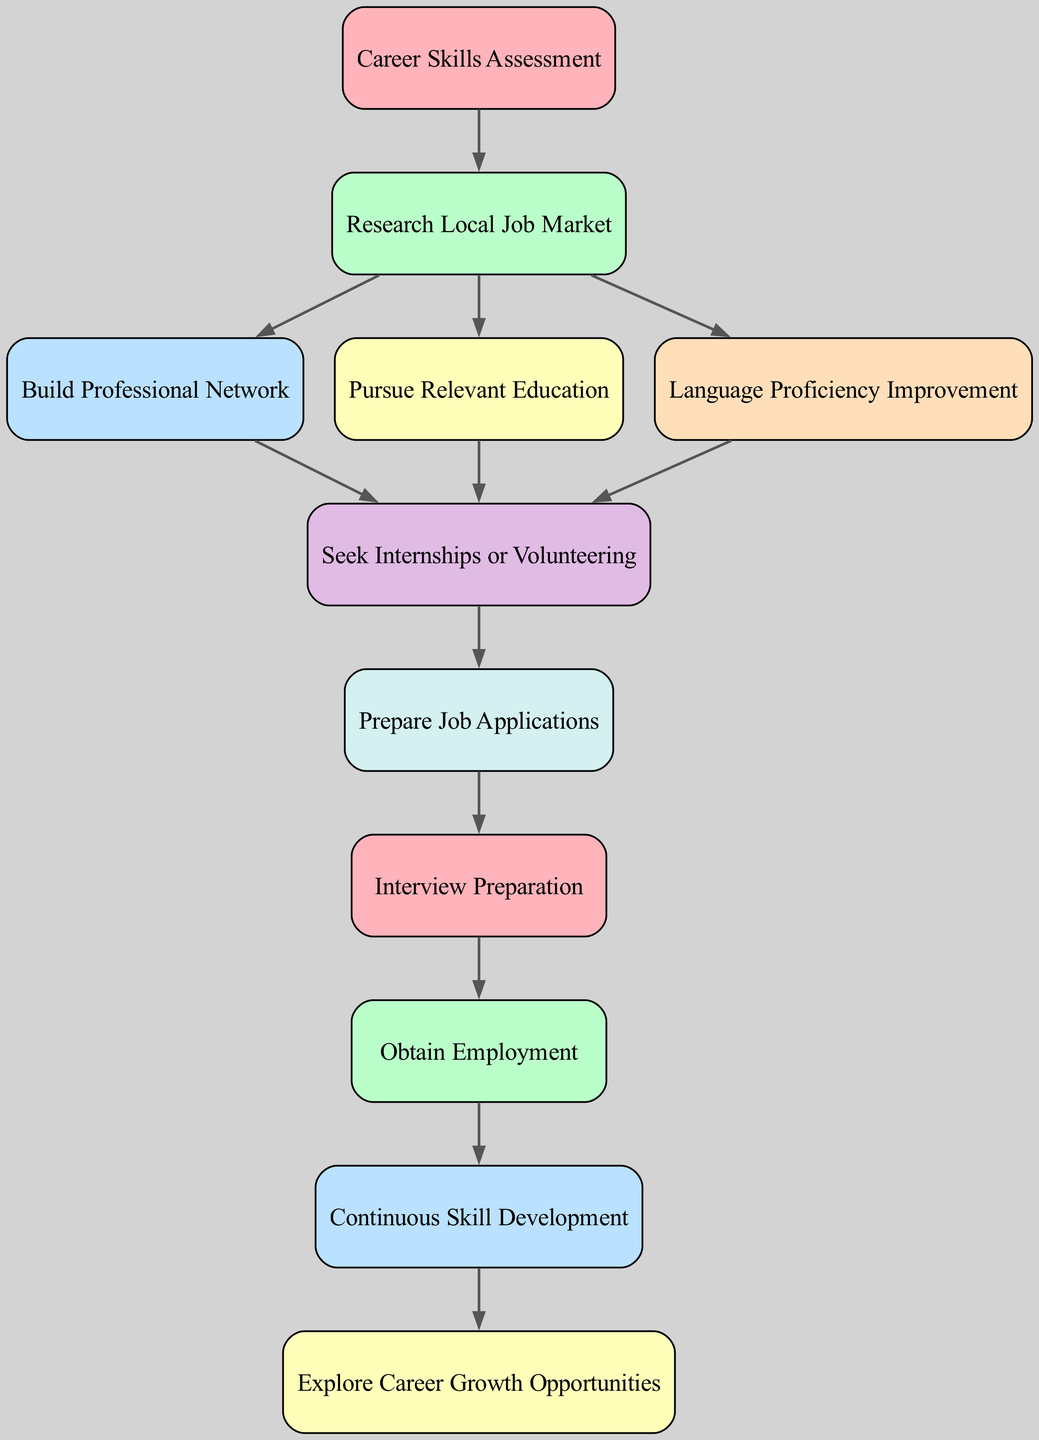What is the first step in the career transition pathway? The diagram indicates that the first step is "Career Skills Assessment," as it is the starting node from which all other nodes progress.
Answer: Career Skills Assessment How many total nodes are present in the diagram? By counting the unique nodes listed, there are ten nodes in total that represent various stages in the career transition pathway.
Answer: 10 Which node comes after "Research Local Job Market"? The diagram shows that "Build Professional Network," "Pursue Relevant Education," and "Language Proficiency Improvement" directly follow the "Research Local Job Market" node, as they are connected by edges leading from Research.
Answer: Build Professional Network, Pursue Relevant Education, Language Proficiency Improvement What is the final outcome of the career pathway? The diagram illustrates that the final outcome after progressing through various steps leads to "Obtain Employment," which is the last node in the diagram.
Answer: Obtain Employment Is "Internship" connected to "Education"? Yes, the diagram shows an edge connecting "Education" directly to "Seek Internships or Volunteering," indicating that pursuing relevant education is a pathway to securing internships.
Answer: Yes Which node is dependent on "Interviews"? The diagram indicates that "Obtain Employment" is dependent on successful "Interview Preparation" as it follows the Interviews node in the pathway.
Answer: Obtain Employment What stage follows "Seek Internships or Volunteering"? The diagram shows that "Prepare Job Applications" directly follows "Seek Internships or Volunteering" in the sequence of steps in the pathway.
Answer: Prepare Job Applications How many edges are in the directed graph? By analyzing the connections between nodes, there are twelve directed edges that represent the pathways connecting the various steps in the career transition process.
Answer: 12 What does "Continuous Skill Development" lead to? The diagram specifies that "Continuous Skill Development" leads to "Explore Career Growth Opportunities," indicating the relationship as a step towards career advancement.
Answer: Explore Career Growth Opportunities 